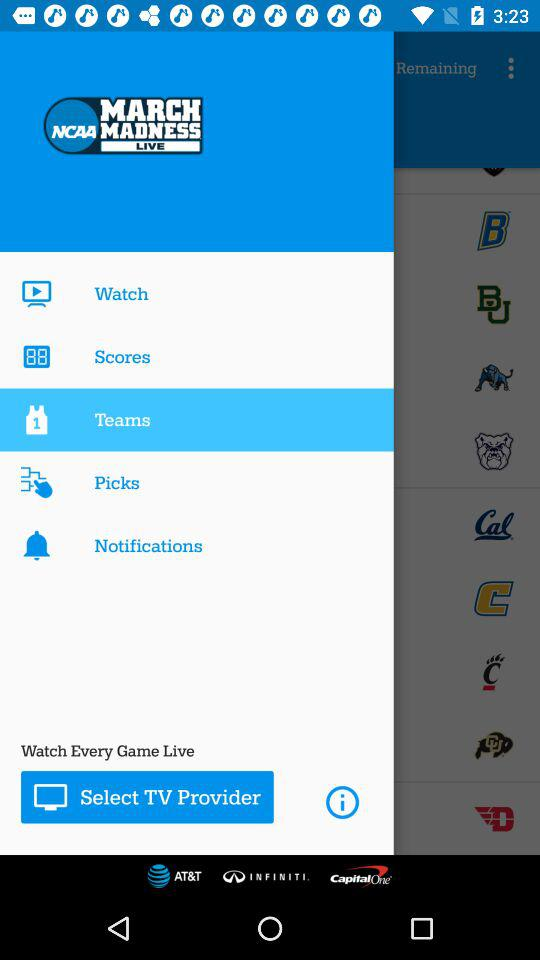What is the selected item in the menu? The selected item in the menu is "Teams". 